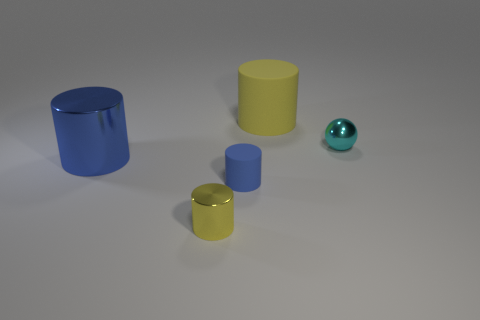Subtract all cyan cylinders. Subtract all green balls. How many cylinders are left? 4 Add 5 red metal cubes. How many objects exist? 10 Subtract all spheres. How many objects are left? 4 Add 3 yellow shiny cylinders. How many yellow shiny cylinders are left? 4 Add 1 brown rubber objects. How many brown rubber objects exist? 1 Subtract 0 blue cubes. How many objects are left? 5 Subtract all small gray metallic cubes. Subtract all cyan spheres. How many objects are left? 4 